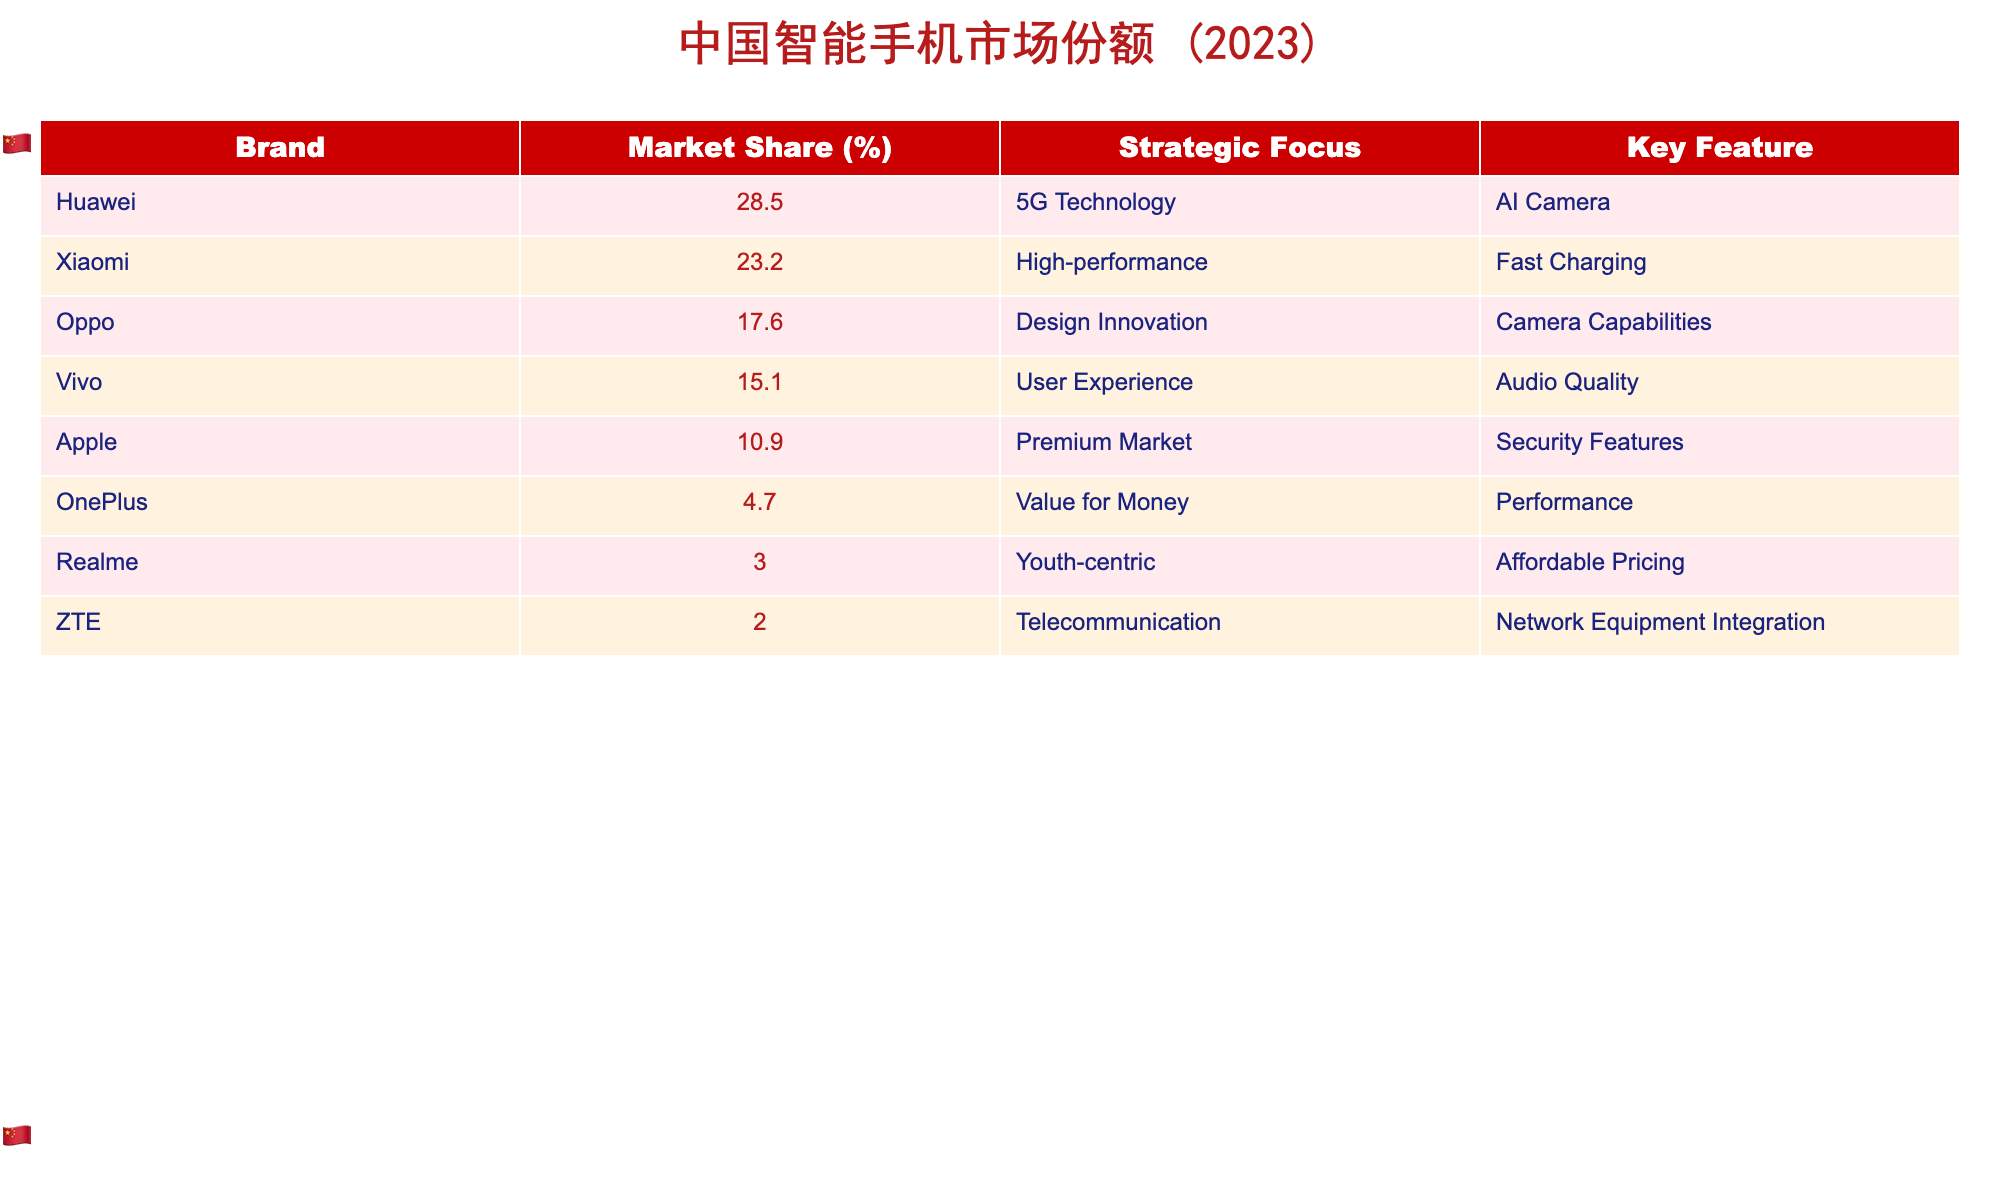What is the market share of Huawei? The table lists Huawei's market share directly as 28.5%.
Answer: 28.5% Which brand has the highest market share? By comparing the market shares listed in the table, Huawei has the highest market share at 28.5%.
Answer: Huawei What is the total market share of all domestic brands? Adding the market shares of Huawei, Xiaomi, Oppo, Vivo, OnePlus, Realme, and ZTE gives 28.5 + 23.2 + 17.6 + 15.1 + 4.7 + 3.0 + 2.0 = 94.1%.
Answer: 94.1% How much higher is Xiaomi’s market share compared to ZTE’s? Subtracting ZTE's market share (2.0%) from Xiaomi's market share (23.2%) gives 23.2 - 2.0 = 21.2%.
Answer: 21.2% Is the statement "Apple has the lowest market share" true based on the table? Comparing market shares shows that Realme (3.0%) has a lower market share than Apple (10.9%), making the statement false.
Answer: No What proportion of the market is covered by the top three domestic brands? The top three domestic brands are Huawei (28.5%), Xiaomi (23.2%), and Oppo (17.6%). Their total is 28.5 + 23.2 + 17.6 = 69.3%.
Answer: 69.3% What is the difference in market share between Vivo and OnePlus? Subtracting OnePlus's market share (4.7%) from Vivo's market share (15.1%) gives 15.1 - 4.7 = 10.4%.
Answer: 10.4% How many brands have a market share of over 10%? The brands with market shares over 10% are Huawei (28.5%), Xiaomi (23.2%), Oppo (17.6%), Vivo (15.1%), and Apple (10.9%) totaling 5 brands.
Answer: 5 If we consider only domestic brands, what is the average market share? The total market share of domestic brands is 94.1% and there are 7 domestic brands, so the average is 94.1 / 7 ≈ 13.4%.
Answer: ≈ 13.4% Which brand focuses on High-performance technology and what is its market share? The table indicates Xiaomi focuses on High-performance technology and has a market share of 23.2%.
Answer: Xiaomi, 23.2% 